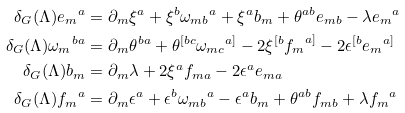<formula> <loc_0><loc_0><loc_500><loc_500>\delta _ { G } ( \Lambda ) { e _ { m } } ^ { a } & = \partial _ { m } \xi ^ { a } + \xi ^ { b } { \omega _ { m b } } ^ { a } + \xi ^ { a } b _ { m } + \theta ^ { a b } e _ { m b } - \lambda { e _ { m } } ^ { a } \\ \delta _ { G } ( \Lambda ) { \omega _ { m } } ^ { b a } & = \partial _ { m } \theta ^ { b a } + \theta ^ { [ b c } { \omega _ { m c } } ^ { a ] } - 2 \xi ^ { [ b } { f _ { m } } ^ { a ] } - 2 \epsilon ^ { [ b } { e _ { m } } ^ { a ] } \\ \delta _ { G } ( \Lambda ) b _ { m } & = \partial _ { m } \lambda + 2 \xi ^ { a } f _ { m a } - 2 \epsilon ^ { a } e _ { m a } \\ \delta _ { G } ( \Lambda ) { f _ { m } } ^ { a } & = \partial _ { m } \epsilon ^ { a } + \epsilon ^ { b } { \omega _ { m b } } ^ { a } - \epsilon ^ { a } b _ { m } + \theta ^ { a b } f _ { m b } + \lambda { f _ { m } } ^ { a }</formula> 